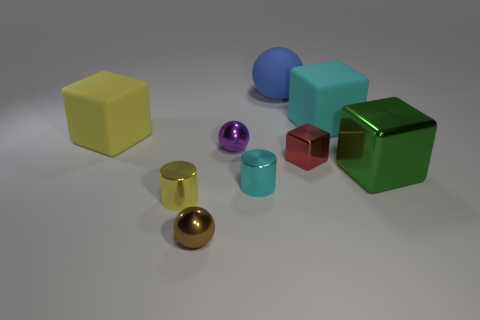Subtract 1 blocks. How many blocks are left? 3 Subtract all brown cubes. Subtract all blue spheres. How many cubes are left? 4 Add 1 green objects. How many objects exist? 10 Subtract all cylinders. How many objects are left? 7 Add 1 tiny purple balls. How many tiny purple balls are left? 2 Add 1 cyan cubes. How many cyan cubes exist? 2 Subtract 0 red cylinders. How many objects are left? 9 Subtract all small yellow shiny cylinders. Subtract all blue matte balls. How many objects are left? 7 